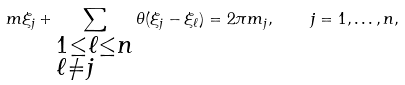Convert formula to latex. <formula><loc_0><loc_0><loc_500><loc_500>m \xi _ { j } + \sum _ { \begin{subarray} { c } 1 \leq \ell \leq n \\ \ell \neq j \end{subarray} } \theta ( \xi _ { j } - \xi _ { \ell } ) = 2 \pi m _ { j } , \quad j = 1 , \dots , n ,</formula> 